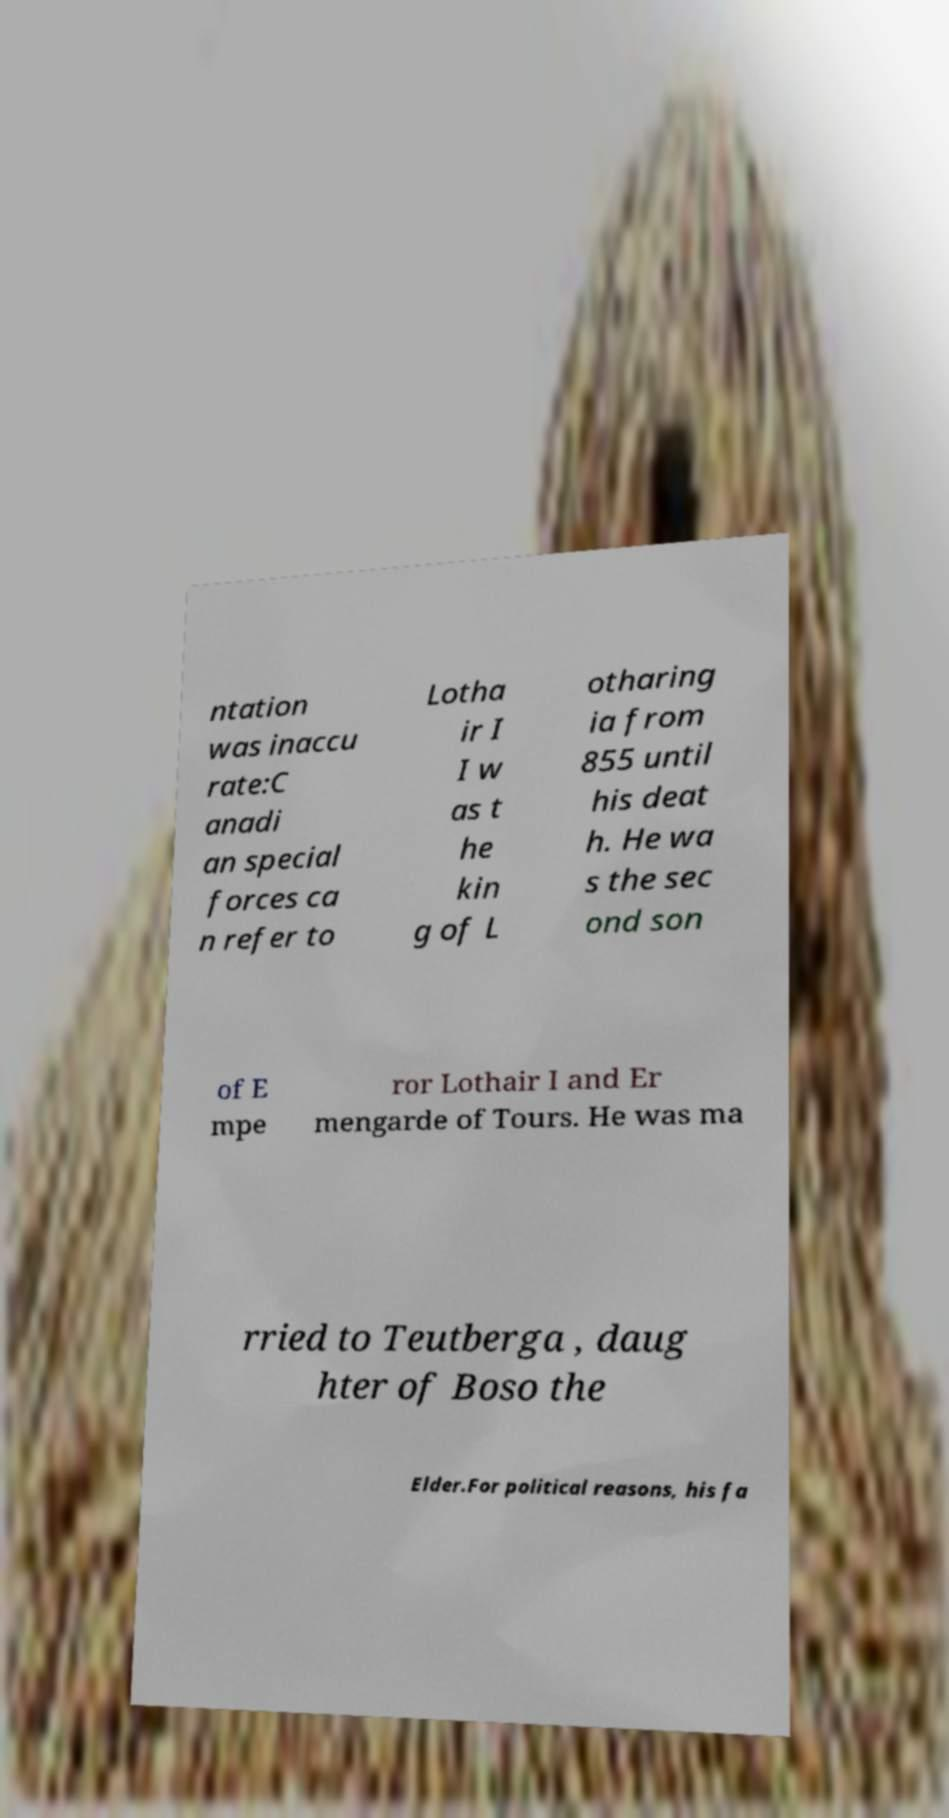Could you extract and type out the text from this image? ntation was inaccu rate:C anadi an special forces ca n refer to Lotha ir I I w as t he kin g of L otharing ia from 855 until his deat h. He wa s the sec ond son of E mpe ror Lothair I and Er mengarde of Tours. He was ma rried to Teutberga , daug hter of Boso the Elder.For political reasons, his fa 